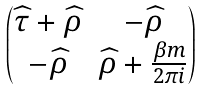<formula> <loc_0><loc_0><loc_500><loc_500>\begin{pmatrix} \widehat { \tau } + \widehat { \rho } & - \widehat { \rho } \\ - \widehat { \rho } & \widehat { \rho } + \frac { \beta m } { 2 \pi i } \end{pmatrix}</formula> 